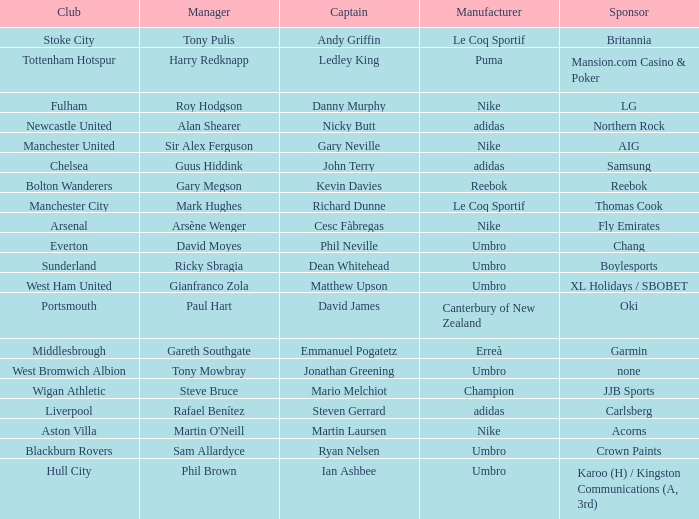Which Manchester United captain is sponsored by Nike? Gary Neville. 